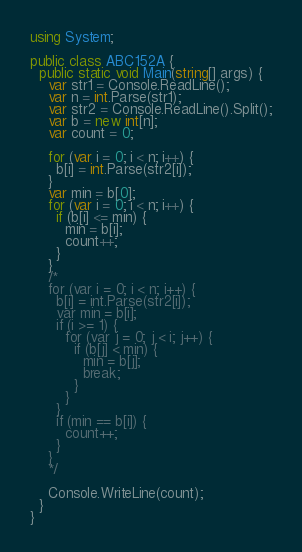Convert code to text. <code><loc_0><loc_0><loc_500><loc_500><_C#_>using System;

public class ABC152A {
  public static void Main(string[] args) {
    var str1 = Console.ReadLine();
    var n = int.Parse(str1);
    var str2 = Console.ReadLine().Split();
    var b = new int[n];
    var count = 0;
    
    for (var i = 0; i < n; i++) {
      b[i] = int.Parse(str2[i]);
    }
    var min = b[0];
    for (var i = 0; i < n; i++) {
      if (b[i] <= min) {
        min = b[i];
        count++;
      }
    }
    /*
    for (var i = 0; i < n; i++) {
      b[i] = int.Parse(str2[i]);
      var min = b[i];
      if (i >= 1) {
        for (var j = 0; j < i; j++) {
          if (b[j] < min) {
            min = b[j];
            break;
          }
        }
      }
      if (min == b[i]) {
        count++;
      }
    }
    */
    
    Console.WriteLine(count);
  }
}</code> 